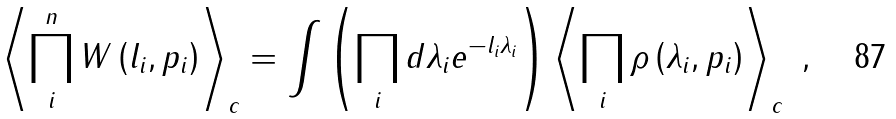<formula> <loc_0><loc_0><loc_500><loc_500>\left < \prod _ { i } ^ { n } W \left ( l _ { i } , p _ { i } \right ) \right > _ { c } = \int \left ( \prod _ { i } d \lambda _ { i } e ^ { - l _ { i } \lambda _ { i } } \right ) \left < \prod _ { i } \rho \left ( \lambda _ { i } , p _ { i } \right ) \right > _ { c } \ ,</formula> 